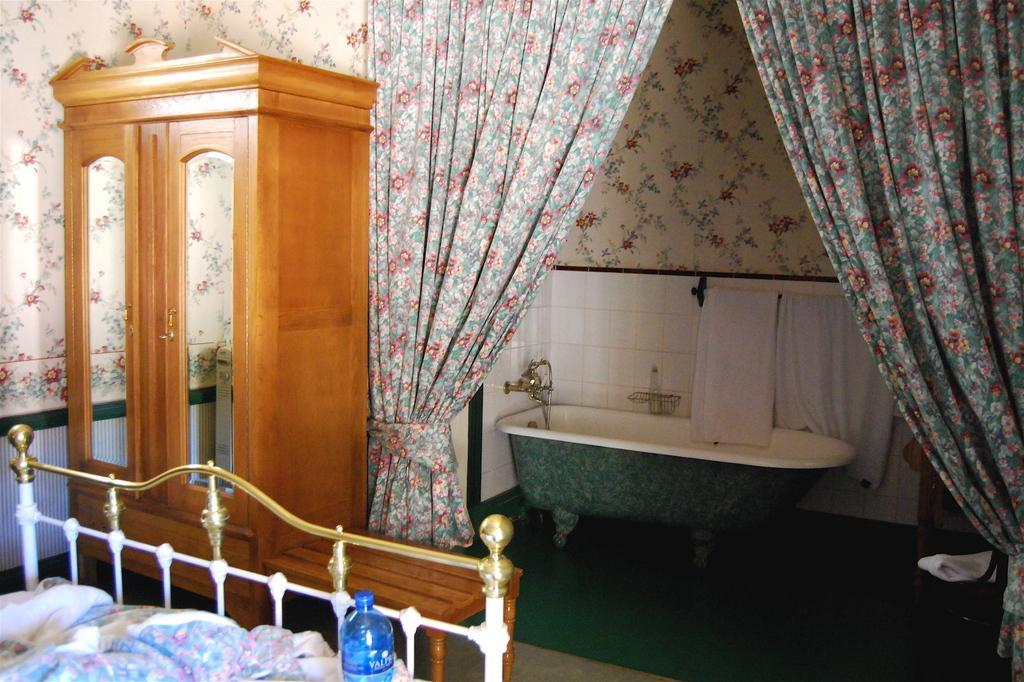Describe this image in one or two sentences. In the image on the left side, we can see one bed, cupboard and mirrors. On the bed, we can see blankets and one water bottle. In the background there is a wall, curtains, one hanger, towels, one bathtub, taps and a few other objects. 